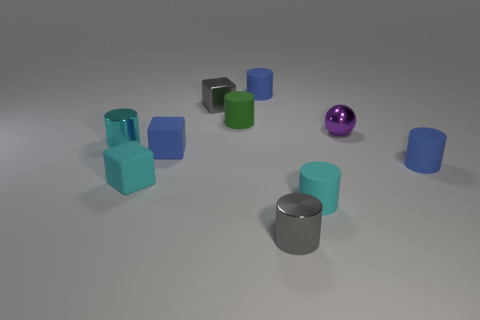Are the small blue object that is behind the small green object and the small sphere made of the same material?
Your response must be concise. No. Is the number of gray cylinders right of the small green cylinder greater than the number of small purple spheres in front of the tiny cyan rubber block?
Keep it short and to the point. Yes. What color is the metal ball that is the same size as the blue block?
Keep it short and to the point. Purple. Are there any small metal things of the same color as the small shiny block?
Keep it short and to the point. Yes. There is a thing that is to the right of the metallic ball; is its color the same as the tiny metal object that is behind the small ball?
Provide a succinct answer. No. What is the block behind the small green rubber cylinder made of?
Provide a short and direct response. Metal. What color is the sphere that is made of the same material as the gray cube?
Offer a terse response. Purple. How many metallic cylinders are the same size as the cyan matte cylinder?
Provide a short and direct response. 2. There is a blue thing on the left side of the metal block; is it the same size as the green rubber cylinder?
Provide a short and direct response. Yes. What is the shape of the tiny matte object that is both left of the small gray shiny cube and in front of the tiny blue rubber block?
Ensure brevity in your answer.  Cube. 